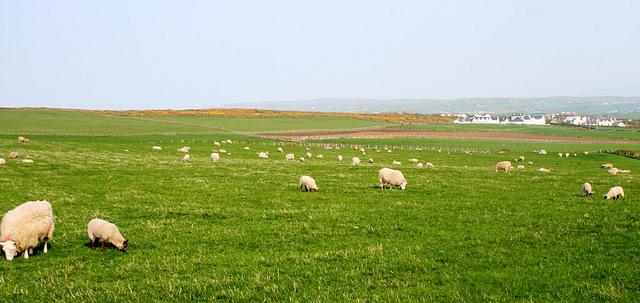What landforms are in the back?
Answer briefly. Hills. What is in the background of the picture?
Keep it brief. Sky. Is this in New Zealand?
Short answer required. Yes. Where was this photo taken?
Concise answer only. Field. Are these pigs?
Keep it brief. No. 